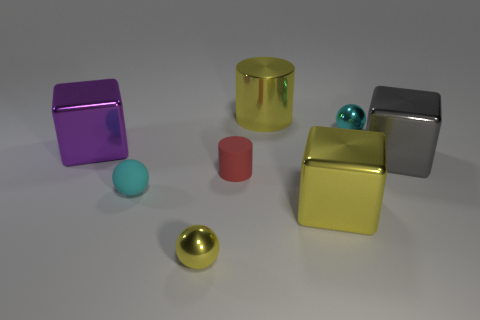Is the number of blocks that are on the left side of the big yellow cylinder greater than the number of purple things in front of the purple object?
Offer a terse response. Yes. Does the tiny thing that is right of the red rubber object have the same color as the small rubber sphere?
Ensure brevity in your answer.  Yes. Is the number of yellow metallic cubes in front of the tiny cyan rubber object greater than the number of cyan matte balls?
Keep it short and to the point. No. Is there anything else that has the same color as the metallic cylinder?
Your response must be concise. Yes. What shape is the tiny cyan thing to the right of the yellow cylinder that is behind the large yellow cube?
Keep it short and to the point. Sphere. Is the number of small blue spheres greater than the number of gray metallic blocks?
Ensure brevity in your answer.  No. How many shiny things are to the right of the matte cylinder and in front of the small red matte thing?
Keep it short and to the point. 1. What number of cyan metal spheres are in front of the tiny cyan sphere behind the tiny red matte cylinder?
Make the answer very short. 0. How many things are shiny things that are left of the large yellow cube or big objects that are on the right side of the large purple thing?
Keep it short and to the point. 5. There is another object that is the same shape as the tiny red rubber object; what is its material?
Give a very brief answer. Metal. 